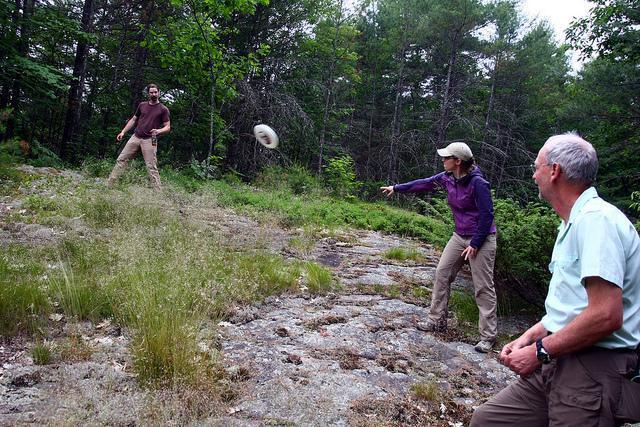How many people are visible?
Give a very brief answer. 3. 